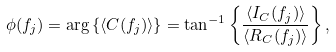<formula> <loc_0><loc_0><loc_500><loc_500>\phi ( f _ { j } ) = \arg \left \{ \langle C ( f _ { j } ) \rangle \right \} = \tan ^ { - 1 } \left \{ \frac { \langle I _ { C } ( f _ { j } ) \rangle } { \langle R _ { C } ( f _ { j } ) \rangle } \right \} ,</formula> 